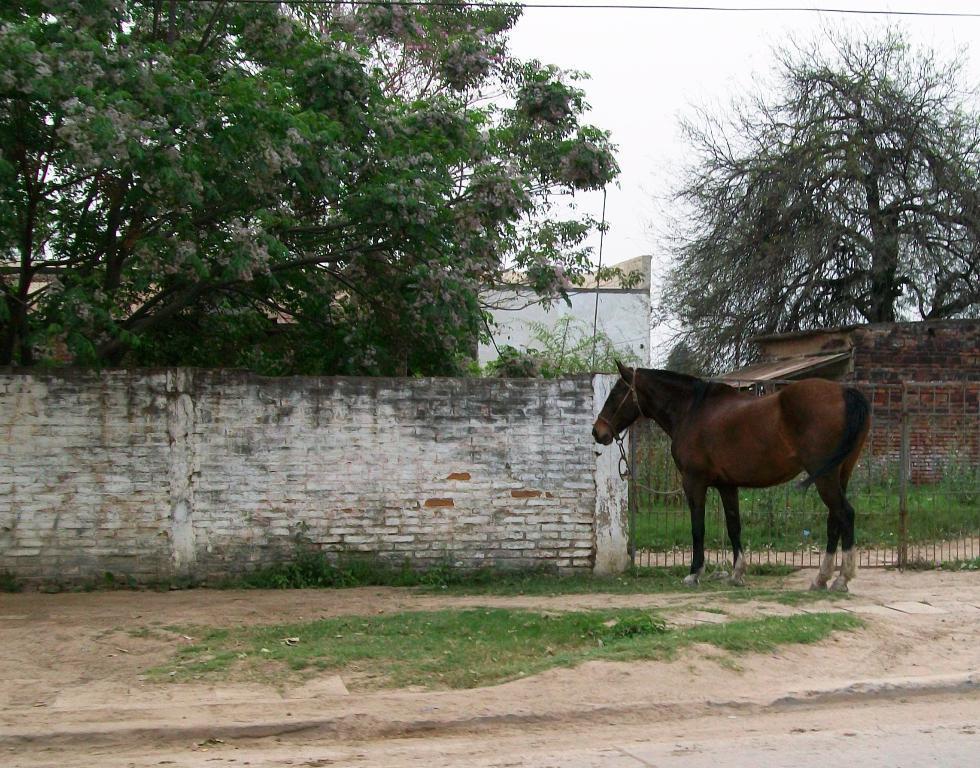Please provide a concise description of this image. At the bottom of the image on the ground there is grass. There is a horse standing. Behind the horse there's a wall with a gate. Behind the wall there are trees and on the ground there is grass. And also there are walls. 